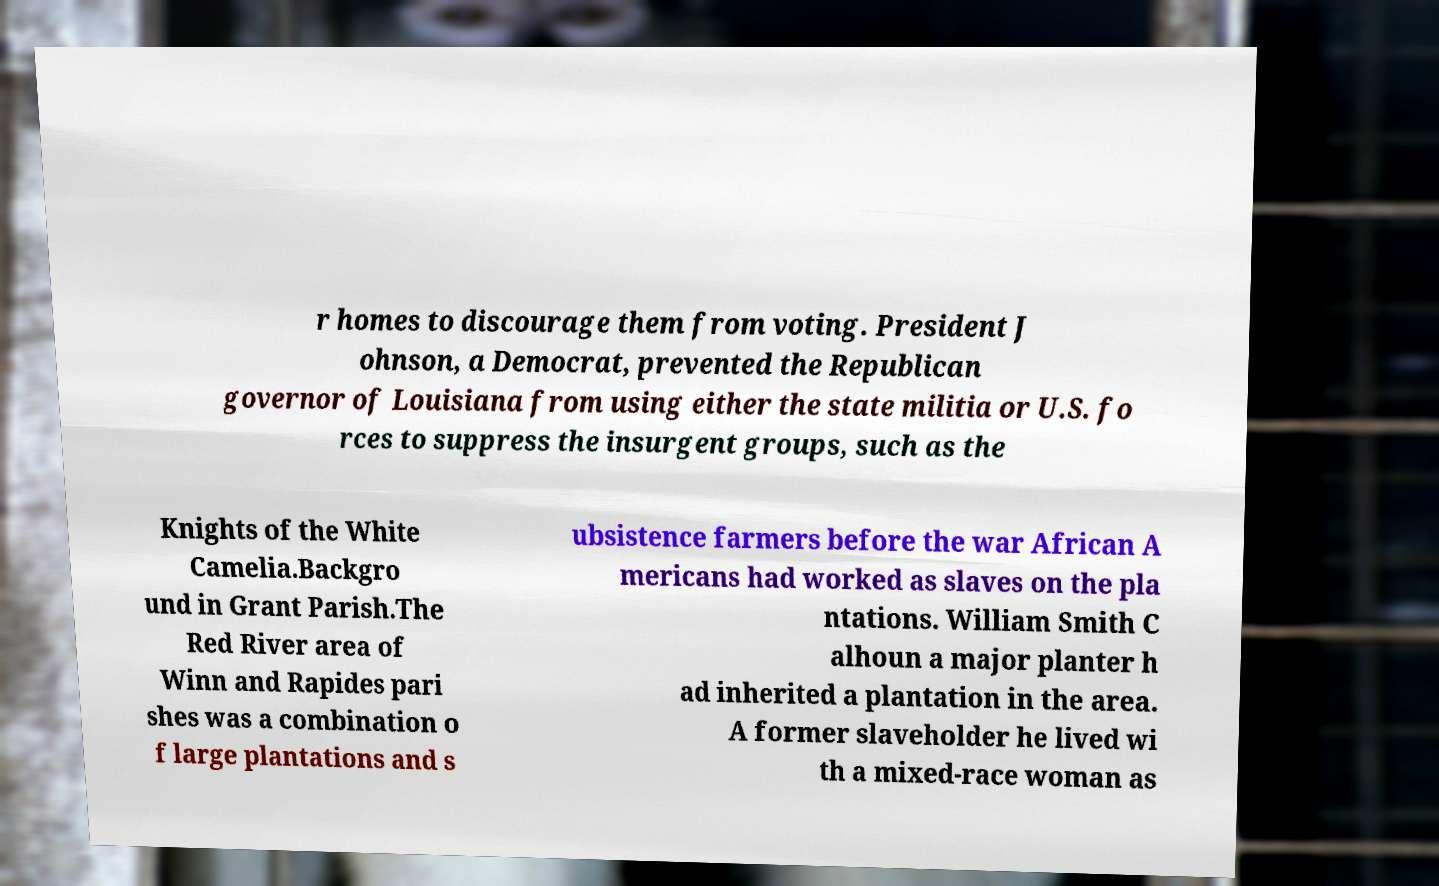Could you assist in decoding the text presented in this image and type it out clearly? r homes to discourage them from voting. President J ohnson, a Democrat, prevented the Republican governor of Louisiana from using either the state militia or U.S. fo rces to suppress the insurgent groups, such as the Knights of the White Camelia.Backgro und in Grant Parish.The Red River area of Winn and Rapides pari shes was a combination o f large plantations and s ubsistence farmers before the war African A mericans had worked as slaves on the pla ntations. William Smith C alhoun a major planter h ad inherited a plantation in the area. A former slaveholder he lived wi th a mixed-race woman as 